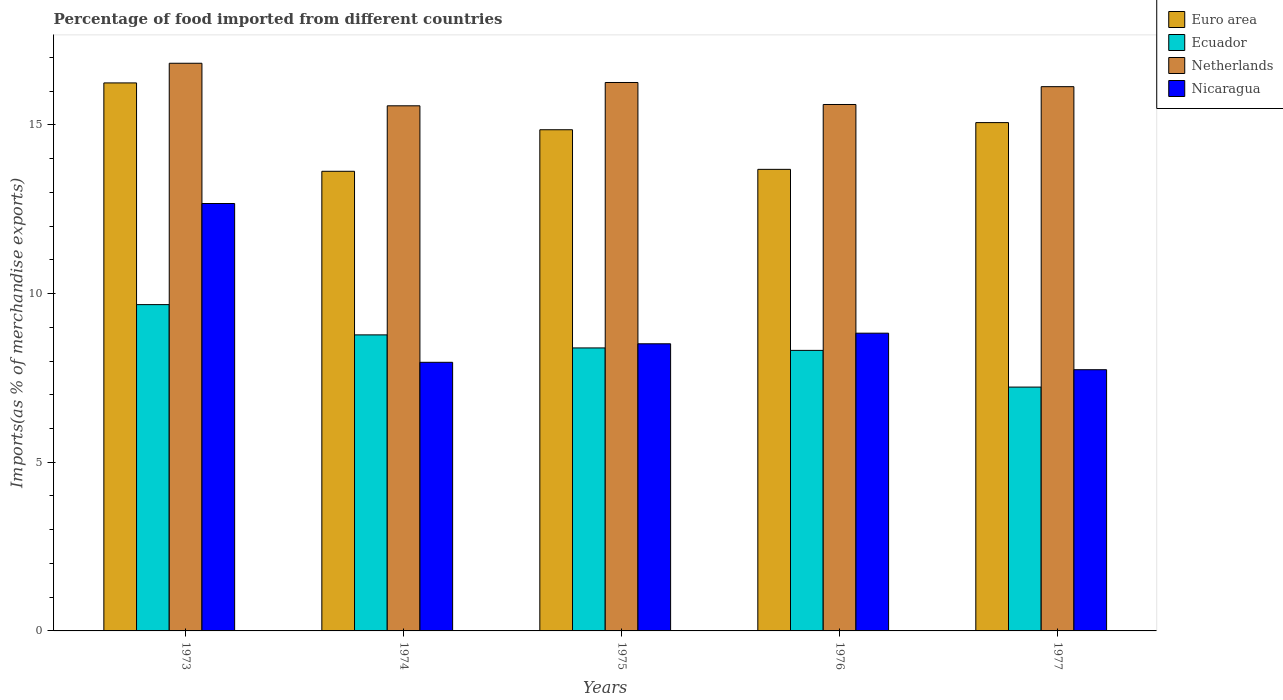How many different coloured bars are there?
Your answer should be compact. 4. Are the number of bars on each tick of the X-axis equal?
Ensure brevity in your answer.  Yes. How many bars are there on the 3rd tick from the right?
Offer a very short reply. 4. What is the label of the 2nd group of bars from the left?
Your answer should be compact. 1974. In how many cases, is the number of bars for a given year not equal to the number of legend labels?
Make the answer very short. 0. What is the percentage of imports to different countries in Ecuador in 1974?
Keep it short and to the point. 8.78. Across all years, what is the maximum percentage of imports to different countries in Nicaragua?
Give a very brief answer. 12.67. Across all years, what is the minimum percentage of imports to different countries in Euro area?
Provide a short and direct response. 13.63. What is the total percentage of imports to different countries in Ecuador in the graph?
Your answer should be compact. 42.38. What is the difference between the percentage of imports to different countries in Ecuador in 1973 and that in 1974?
Provide a succinct answer. 0.9. What is the difference between the percentage of imports to different countries in Ecuador in 1973 and the percentage of imports to different countries in Nicaragua in 1977?
Your answer should be compact. 1.93. What is the average percentage of imports to different countries in Euro area per year?
Provide a short and direct response. 14.7. In the year 1974, what is the difference between the percentage of imports to different countries in Ecuador and percentage of imports to different countries in Netherlands?
Your response must be concise. -6.79. In how many years, is the percentage of imports to different countries in Ecuador greater than 1 %?
Ensure brevity in your answer.  5. What is the ratio of the percentage of imports to different countries in Euro area in 1973 to that in 1977?
Keep it short and to the point. 1.08. Is the percentage of imports to different countries in Ecuador in 1974 less than that in 1977?
Make the answer very short. No. Is the difference between the percentage of imports to different countries in Ecuador in 1974 and 1975 greater than the difference between the percentage of imports to different countries in Netherlands in 1974 and 1975?
Ensure brevity in your answer.  Yes. What is the difference between the highest and the second highest percentage of imports to different countries in Netherlands?
Make the answer very short. 0.57. What is the difference between the highest and the lowest percentage of imports to different countries in Euro area?
Offer a terse response. 2.62. In how many years, is the percentage of imports to different countries in Ecuador greater than the average percentage of imports to different countries in Ecuador taken over all years?
Your answer should be compact. 2. Is it the case that in every year, the sum of the percentage of imports to different countries in Euro area and percentage of imports to different countries in Nicaragua is greater than the sum of percentage of imports to different countries in Ecuador and percentage of imports to different countries in Netherlands?
Offer a very short reply. No. What does the 1st bar from the right in 1976 represents?
Offer a terse response. Nicaragua. Are all the bars in the graph horizontal?
Give a very brief answer. No. What is the difference between two consecutive major ticks on the Y-axis?
Your answer should be very brief. 5. Does the graph contain grids?
Provide a succinct answer. No. Where does the legend appear in the graph?
Offer a terse response. Top right. How are the legend labels stacked?
Keep it short and to the point. Vertical. What is the title of the graph?
Keep it short and to the point. Percentage of food imported from different countries. Does "Malaysia" appear as one of the legend labels in the graph?
Keep it short and to the point. No. What is the label or title of the Y-axis?
Provide a short and direct response. Imports(as % of merchandise exports). What is the Imports(as % of merchandise exports) in Euro area in 1973?
Offer a terse response. 16.25. What is the Imports(as % of merchandise exports) of Ecuador in 1973?
Your response must be concise. 9.67. What is the Imports(as % of merchandise exports) of Netherlands in 1973?
Your response must be concise. 16.83. What is the Imports(as % of merchandise exports) in Nicaragua in 1973?
Offer a terse response. 12.67. What is the Imports(as % of merchandise exports) of Euro area in 1974?
Ensure brevity in your answer.  13.63. What is the Imports(as % of merchandise exports) of Ecuador in 1974?
Your response must be concise. 8.78. What is the Imports(as % of merchandise exports) in Netherlands in 1974?
Give a very brief answer. 15.57. What is the Imports(as % of merchandise exports) of Nicaragua in 1974?
Provide a short and direct response. 7.96. What is the Imports(as % of merchandise exports) of Euro area in 1975?
Provide a succinct answer. 14.86. What is the Imports(as % of merchandise exports) of Ecuador in 1975?
Provide a short and direct response. 8.39. What is the Imports(as % of merchandise exports) of Netherlands in 1975?
Give a very brief answer. 16.26. What is the Imports(as % of merchandise exports) in Nicaragua in 1975?
Ensure brevity in your answer.  8.51. What is the Imports(as % of merchandise exports) in Euro area in 1976?
Give a very brief answer. 13.68. What is the Imports(as % of merchandise exports) of Ecuador in 1976?
Make the answer very short. 8.32. What is the Imports(as % of merchandise exports) of Netherlands in 1976?
Your answer should be very brief. 15.61. What is the Imports(as % of merchandise exports) of Nicaragua in 1976?
Provide a short and direct response. 8.83. What is the Imports(as % of merchandise exports) of Euro area in 1977?
Your answer should be compact. 15.07. What is the Imports(as % of merchandise exports) of Ecuador in 1977?
Make the answer very short. 7.23. What is the Imports(as % of merchandise exports) of Netherlands in 1977?
Your answer should be very brief. 16.13. What is the Imports(as % of merchandise exports) of Nicaragua in 1977?
Provide a succinct answer. 7.74. Across all years, what is the maximum Imports(as % of merchandise exports) of Euro area?
Give a very brief answer. 16.25. Across all years, what is the maximum Imports(as % of merchandise exports) in Ecuador?
Offer a very short reply. 9.67. Across all years, what is the maximum Imports(as % of merchandise exports) of Netherlands?
Provide a succinct answer. 16.83. Across all years, what is the maximum Imports(as % of merchandise exports) in Nicaragua?
Offer a terse response. 12.67. Across all years, what is the minimum Imports(as % of merchandise exports) of Euro area?
Make the answer very short. 13.63. Across all years, what is the minimum Imports(as % of merchandise exports) in Ecuador?
Make the answer very short. 7.23. Across all years, what is the minimum Imports(as % of merchandise exports) of Netherlands?
Your answer should be very brief. 15.57. Across all years, what is the minimum Imports(as % of merchandise exports) in Nicaragua?
Offer a terse response. 7.74. What is the total Imports(as % of merchandise exports) of Euro area in the graph?
Offer a very short reply. 73.48. What is the total Imports(as % of merchandise exports) in Ecuador in the graph?
Give a very brief answer. 42.38. What is the total Imports(as % of merchandise exports) in Netherlands in the graph?
Make the answer very short. 80.39. What is the total Imports(as % of merchandise exports) of Nicaragua in the graph?
Offer a very short reply. 45.71. What is the difference between the Imports(as % of merchandise exports) in Euro area in 1973 and that in 1974?
Make the answer very short. 2.62. What is the difference between the Imports(as % of merchandise exports) of Ecuador in 1973 and that in 1974?
Ensure brevity in your answer.  0.9. What is the difference between the Imports(as % of merchandise exports) in Netherlands in 1973 and that in 1974?
Make the answer very short. 1.26. What is the difference between the Imports(as % of merchandise exports) in Nicaragua in 1973 and that in 1974?
Your answer should be very brief. 4.71. What is the difference between the Imports(as % of merchandise exports) in Euro area in 1973 and that in 1975?
Make the answer very short. 1.39. What is the difference between the Imports(as % of merchandise exports) in Ecuador in 1973 and that in 1975?
Give a very brief answer. 1.28. What is the difference between the Imports(as % of merchandise exports) of Netherlands in 1973 and that in 1975?
Offer a very short reply. 0.57. What is the difference between the Imports(as % of merchandise exports) in Nicaragua in 1973 and that in 1975?
Offer a very short reply. 4.16. What is the difference between the Imports(as % of merchandise exports) of Euro area in 1973 and that in 1976?
Your answer should be very brief. 2.56. What is the difference between the Imports(as % of merchandise exports) of Ecuador in 1973 and that in 1976?
Ensure brevity in your answer.  1.36. What is the difference between the Imports(as % of merchandise exports) in Netherlands in 1973 and that in 1976?
Give a very brief answer. 1.22. What is the difference between the Imports(as % of merchandise exports) in Nicaragua in 1973 and that in 1976?
Your response must be concise. 3.84. What is the difference between the Imports(as % of merchandise exports) in Euro area in 1973 and that in 1977?
Ensure brevity in your answer.  1.18. What is the difference between the Imports(as % of merchandise exports) in Ecuador in 1973 and that in 1977?
Give a very brief answer. 2.44. What is the difference between the Imports(as % of merchandise exports) in Netherlands in 1973 and that in 1977?
Your response must be concise. 0.69. What is the difference between the Imports(as % of merchandise exports) of Nicaragua in 1973 and that in 1977?
Offer a very short reply. 4.93. What is the difference between the Imports(as % of merchandise exports) in Euro area in 1974 and that in 1975?
Your answer should be very brief. -1.23. What is the difference between the Imports(as % of merchandise exports) in Ecuador in 1974 and that in 1975?
Provide a short and direct response. 0.39. What is the difference between the Imports(as % of merchandise exports) in Netherlands in 1974 and that in 1975?
Your response must be concise. -0.69. What is the difference between the Imports(as % of merchandise exports) of Nicaragua in 1974 and that in 1975?
Offer a terse response. -0.55. What is the difference between the Imports(as % of merchandise exports) in Euro area in 1974 and that in 1976?
Your answer should be compact. -0.06. What is the difference between the Imports(as % of merchandise exports) in Ecuador in 1974 and that in 1976?
Provide a short and direct response. 0.46. What is the difference between the Imports(as % of merchandise exports) of Netherlands in 1974 and that in 1976?
Offer a very short reply. -0.04. What is the difference between the Imports(as % of merchandise exports) in Nicaragua in 1974 and that in 1976?
Provide a succinct answer. -0.86. What is the difference between the Imports(as % of merchandise exports) in Euro area in 1974 and that in 1977?
Give a very brief answer. -1.44. What is the difference between the Imports(as % of merchandise exports) in Ecuador in 1974 and that in 1977?
Provide a short and direct response. 1.55. What is the difference between the Imports(as % of merchandise exports) in Netherlands in 1974 and that in 1977?
Provide a short and direct response. -0.57. What is the difference between the Imports(as % of merchandise exports) in Nicaragua in 1974 and that in 1977?
Provide a succinct answer. 0.22. What is the difference between the Imports(as % of merchandise exports) in Euro area in 1975 and that in 1976?
Offer a very short reply. 1.17. What is the difference between the Imports(as % of merchandise exports) of Ecuador in 1975 and that in 1976?
Give a very brief answer. 0.07. What is the difference between the Imports(as % of merchandise exports) in Netherlands in 1975 and that in 1976?
Keep it short and to the point. 0.65. What is the difference between the Imports(as % of merchandise exports) of Nicaragua in 1975 and that in 1976?
Offer a terse response. -0.31. What is the difference between the Imports(as % of merchandise exports) in Euro area in 1975 and that in 1977?
Your answer should be very brief. -0.21. What is the difference between the Imports(as % of merchandise exports) of Ecuador in 1975 and that in 1977?
Ensure brevity in your answer.  1.16. What is the difference between the Imports(as % of merchandise exports) in Netherlands in 1975 and that in 1977?
Your answer should be very brief. 0.12. What is the difference between the Imports(as % of merchandise exports) of Nicaragua in 1975 and that in 1977?
Make the answer very short. 0.77. What is the difference between the Imports(as % of merchandise exports) of Euro area in 1976 and that in 1977?
Make the answer very short. -1.39. What is the difference between the Imports(as % of merchandise exports) of Ecuador in 1976 and that in 1977?
Keep it short and to the point. 1.09. What is the difference between the Imports(as % of merchandise exports) of Netherlands in 1976 and that in 1977?
Offer a very short reply. -0.53. What is the difference between the Imports(as % of merchandise exports) in Nicaragua in 1976 and that in 1977?
Make the answer very short. 1.08. What is the difference between the Imports(as % of merchandise exports) in Euro area in 1973 and the Imports(as % of merchandise exports) in Ecuador in 1974?
Provide a succinct answer. 7.47. What is the difference between the Imports(as % of merchandise exports) of Euro area in 1973 and the Imports(as % of merchandise exports) of Netherlands in 1974?
Your answer should be compact. 0.68. What is the difference between the Imports(as % of merchandise exports) in Euro area in 1973 and the Imports(as % of merchandise exports) in Nicaragua in 1974?
Ensure brevity in your answer.  8.28. What is the difference between the Imports(as % of merchandise exports) of Ecuador in 1973 and the Imports(as % of merchandise exports) of Netherlands in 1974?
Ensure brevity in your answer.  -5.89. What is the difference between the Imports(as % of merchandise exports) in Ecuador in 1973 and the Imports(as % of merchandise exports) in Nicaragua in 1974?
Ensure brevity in your answer.  1.71. What is the difference between the Imports(as % of merchandise exports) in Netherlands in 1973 and the Imports(as % of merchandise exports) in Nicaragua in 1974?
Provide a succinct answer. 8.86. What is the difference between the Imports(as % of merchandise exports) in Euro area in 1973 and the Imports(as % of merchandise exports) in Ecuador in 1975?
Your answer should be very brief. 7.86. What is the difference between the Imports(as % of merchandise exports) of Euro area in 1973 and the Imports(as % of merchandise exports) of Netherlands in 1975?
Your answer should be very brief. -0.01. What is the difference between the Imports(as % of merchandise exports) in Euro area in 1973 and the Imports(as % of merchandise exports) in Nicaragua in 1975?
Your answer should be compact. 7.73. What is the difference between the Imports(as % of merchandise exports) in Ecuador in 1973 and the Imports(as % of merchandise exports) in Netherlands in 1975?
Your response must be concise. -6.58. What is the difference between the Imports(as % of merchandise exports) in Ecuador in 1973 and the Imports(as % of merchandise exports) in Nicaragua in 1975?
Offer a terse response. 1.16. What is the difference between the Imports(as % of merchandise exports) in Netherlands in 1973 and the Imports(as % of merchandise exports) in Nicaragua in 1975?
Your answer should be very brief. 8.32. What is the difference between the Imports(as % of merchandise exports) in Euro area in 1973 and the Imports(as % of merchandise exports) in Ecuador in 1976?
Your answer should be compact. 7.93. What is the difference between the Imports(as % of merchandise exports) in Euro area in 1973 and the Imports(as % of merchandise exports) in Netherlands in 1976?
Your answer should be compact. 0.64. What is the difference between the Imports(as % of merchandise exports) in Euro area in 1973 and the Imports(as % of merchandise exports) in Nicaragua in 1976?
Your answer should be very brief. 7.42. What is the difference between the Imports(as % of merchandise exports) of Ecuador in 1973 and the Imports(as % of merchandise exports) of Netherlands in 1976?
Your response must be concise. -5.93. What is the difference between the Imports(as % of merchandise exports) in Ecuador in 1973 and the Imports(as % of merchandise exports) in Nicaragua in 1976?
Offer a very short reply. 0.85. What is the difference between the Imports(as % of merchandise exports) of Netherlands in 1973 and the Imports(as % of merchandise exports) of Nicaragua in 1976?
Provide a short and direct response. 8. What is the difference between the Imports(as % of merchandise exports) in Euro area in 1973 and the Imports(as % of merchandise exports) in Ecuador in 1977?
Your answer should be very brief. 9.02. What is the difference between the Imports(as % of merchandise exports) of Euro area in 1973 and the Imports(as % of merchandise exports) of Netherlands in 1977?
Provide a short and direct response. 0.11. What is the difference between the Imports(as % of merchandise exports) in Euro area in 1973 and the Imports(as % of merchandise exports) in Nicaragua in 1977?
Your response must be concise. 8.5. What is the difference between the Imports(as % of merchandise exports) of Ecuador in 1973 and the Imports(as % of merchandise exports) of Netherlands in 1977?
Offer a terse response. -6.46. What is the difference between the Imports(as % of merchandise exports) of Ecuador in 1973 and the Imports(as % of merchandise exports) of Nicaragua in 1977?
Make the answer very short. 1.93. What is the difference between the Imports(as % of merchandise exports) in Netherlands in 1973 and the Imports(as % of merchandise exports) in Nicaragua in 1977?
Offer a terse response. 9.08. What is the difference between the Imports(as % of merchandise exports) of Euro area in 1974 and the Imports(as % of merchandise exports) of Ecuador in 1975?
Keep it short and to the point. 5.24. What is the difference between the Imports(as % of merchandise exports) in Euro area in 1974 and the Imports(as % of merchandise exports) in Netherlands in 1975?
Provide a succinct answer. -2.63. What is the difference between the Imports(as % of merchandise exports) of Euro area in 1974 and the Imports(as % of merchandise exports) of Nicaragua in 1975?
Give a very brief answer. 5.11. What is the difference between the Imports(as % of merchandise exports) in Ecuador in 1974 and the Imports(as % of merchandise exports) in Netherlands in 1975?
Provide a succinct answer. -7.48. What is the difference between the Imports(as % of merchandise exports) in Ecuador in 1974 and the Imports(as % of merchandise exports) in Nicaragua in 1975?
Your answer should be very brief. 0.26. What is the difference between the Imports(as % of merchandise exports) in Netherlands in 1974 and the Imports(as % of merchandise exports) in Nicaragua in 1975?
Offer a terse response. 7.06. What is the difference between the Imports(as % of merchandise exports) in Euro area in 1974 and the Imports(as % of merchandise exports) in Ecuador in 1976?
Keep it short and to the point. 5.31. What is the difference between the Imports(as % of merchandise exports) in Euro area in 1974 and the Imports(as % of merchandise exports) in Netherlands in 1976?
Provide a short and direct response. -1.98. What is the difference between the Imports(as % of merchandise exports) in Euro area in 1974 and the Imports(as % of merchandise exports) in Nicaragua in 1976?
Provide a succinct answer. 4.8. What is the difference between the Imports(as % of merchandise exports) in Ecuador in 1974 and the Imports(as % of merchandise exports) in Netherlands in 1976?
Provide a short and direct response. -6.83. What is the difference between the Imports(as % of merchandise exports) in Ecuador in 1974 and the Imports(as % of merchandise exports) in Nicaragua in 1976?
Provide a succinct answer. -0.05. What is the difference between the Imports(as % of merchandise exports) in Netherlands in 1974 and the Imports(as % of merchandise exports) in Nicaragua in 1976?
Ensure brevity in your answer.  6.74. What is the difference between the Imports(as % of merchandise exports) of Euro area in 1974 and the Imports(as % of merchandise exports) of Ecuador in 1977?
Provide a succinct answer. 6.4. What is the difference between the Imports(as % of merchandise exports) of Euro area in 1974 and the Imports(as % of merchandise exports) of Netherlands in 1977?
Give a very brief answer. -2.51. What is the difference between the Imports(as % of merchandise exports) of Euro area in 1974 and the Imports(as % of merchandise exports) of Nicaragua in 1977?
Give a very brief answer. 5.88. What is the difference between the Imports(as % of merchandise exports) in Ecuador in 1974 and the Imports(as % of merchandise exports) in Netherlands in 1977?
Your response must be concise. -7.36. What is the difference between the Imports(as % of merchandise exports) of Ecuador in 1974 and the Imports(as % of merchandise exports) of Nicaragua in 1977?
Ensure brevity in your answer.  1.03. What is the difference between the Imports(as % of merchandise exports) in Netherlands in 1974 and the Imports(as % of merchandise exports) in Nicaragua in 1977?
Offer a very short reply. 7.82. What is the difference between the Imports(as % of merchandise exports) in Euro area in 1975 and the Imports(as % of merchandise exports) in Ecuador in 1976?
Offer a terse response. 6.54. What is the difference between the Imports(as % of merchandise exports) in Euro area in 1975 and the Imports(as % of merchandise exports) in Netherlands in 1976?
Provide a short and direct response. -0.75. What is the difference between the Imports(as % of merchandise exports) in Euro area in 1975 and the Imports(as % of merchandise exports) in Nicaragua in 1976?
Keep it short and to the point. 6.03. What is the difference between the Imports(as % of merchandise exports) in Ecuador in 1975 and the Imports(as % of merchandise exports) in Netherlands in 1976?
Give a very brief answer. -7.22. What is the difference between the Imports(as % of merchandise exports) of Ecuador in 1975 and the Imports(as % of merchandise exports) of Nicaragua in 1976?
Ensure brevity in your answer.  -0.44. What is the difference between the Imports(as % of merchandise exports) in Netherlands in 1975 and the Imports(as % of merchandise exports) in Nicaragua in 1976?
Offer a terse response. 7.43. What is the difference between the Imports(as % of merchandise exports) in Euro area in 1975 and the Imports(as % of merchandise exports) in Ecuador in 1977?
Offer a very short reply. 7.63. What is the difference between the Imports(as % of merchandise exports) of Euro area in 1975 and the Imports(as % of merchandise exports) of Netherlands in 1977?
Your response must be concise. -1.28. What is the difference between the Imports(as % of merchandise exports) in Euro area in 1975 and the Imports(as % of merchandise exports) in Nicaragua in 1977?
Your answer should be very brief. 7.11. What is the difference between the Imports(as % of merchandise exports) in Ecuador in 1975 and the Imports(as % of merchandise exports) in Netherlands in 1977?
Keep it short and to the point. -7.75. What is the difference between the Imports(as % of merchandise exports) in Ecuador in 1975 and the Imports(as % of merchandise exports) in Nicaragua in 1977?
Provide a short and direct response. 0.65. What is the difference between the Imports(as % of merchandise exports) of Netherlands in 1975 and the Imports(as % of merchandise exports) of Nicaragua in 1977?
Provide a short and direct response. 8.51. What is the difference between the Imports(as % of merchandise exports) in Euro area in 1976 and the Imports(as % of merchandise exports) in Ecuador in 1977?
Give a very brief answer. 6.45. What is the difference between the Imports(as % of merchandise exports) in Euro area in 1976 and the Imports(as % of merchandise exports) in Netherlands in 1977?
Your response must be concise. -2.45. What is the difference between the Imports(as % of merchandise exports) in Euro area in 1976 and the Imports(as % of merchandise exports) in Nicaragua in 1977?
Give a very brief answer. 5.94. What is the difference between the Imports(as % of merchandise exports) in Ecuador in 1976 and the Imports(as % of merchandise exports) in Netherlands in 1977?
Give a very brief answer. -7.82. What is the difference between the Imports(as % of merchandise exports) in Ecuador in 1976 and the Imports(as % of merchandise exports) in Nicaragua in 1977?
Ensure brevity in your answer.  0.57. What is the difference between the Imports(as % of merchandise exports) in Netherlands in 1976 and the Imports(as % of merchandise exports) in Nicaragua in 1977?
Provide a succinct answer. 7.86. What is the average Imports(as % of merchandise exports) of Euro area per year?
Your answer should be very brief. 14.7. What is the average Imports(as % of merchandise exports) of Ecuador per year?
Provide a short and direct response. 8.48. What is the average Imports(as % of merchandise exports) in Netherlands per year?
Provide a succinct answer. 16.08. What is the average Imports(as % of merchandise exports) in Nicaragua per year?
Offer a terse response. 9.14. In the year 1973, what is the difference between the Imports(as % of merchandise exports) in Euro area and Imports(as % of merchandise exports) in Ecuador?
Keep it short and to the point. 6.57. In the year 1973, what is the difference between the Imports(as % of merchandise exports) of Euro area and Imports(as % of merchandise exports) of Netherlands?
Ensure brevity in your answer.  -0.58. In the year 1973, what is the difference between the Imports(as % of merchandise exports) of Euro area and Imports(as % of merchandise exports) of Nicaragua?
Your answer should be very brief. 3.57. In the year 1973, what is the difference between the Imports(as % of merchandise exports) in Ecuador and Imports(as % of merchandise exports) in Netherlands?
Offer a very short reply. -7.16. In the year 1973, what is the difference between the Imports(as % of merchandise exports) of Ecuador and Imports(as % of merchandise exports) of Nicaragua?
Provide a short and direct response. -3. In the year 1973, what is the difference between the Imports(as % of merchandise exports) in Netherlands and Imports(as % of merchandise exports) in Nicaragua?
Ensure brevity in your answer.  4.16. In the year 1974, what is the difference between the Imports(as % of merchandise exports) of Euro area and Imports(as % of merchandise exports) of Ecuador?
Provide a short and direct response. 4.85. In the year 1974, what is the difference between the Imports(as % of merchandise exports) of Euro area and Imports(as % of merchandise exports) of Netherlands?
Ensure brevity in your answer.  -1.94. In the year 1974, what is the difference between the Imports(as % of merchandise exports) in Euro area and Imports(as % of merchandise exports) in Nicaragua?
Your answer should be very brief. 5.66. In the year 1974, what is the difference between the Imports(as % of merchandise exports) in Ecuador and Imports(as % of merchandise exports) in Netherlands?
Your answer should be compact. -6.79. In the year 1974, what is the difference between the Imports(as % of merchandise exports) in Ecuador and Imports(as % of merchandise exports) in Nicaragua?
Offer a terse response. 0.81. In the year 1974, what is the difference between the Imports(as % of merchandise exports) in Netherlands and Imports(as % of merchandise exports) in Nicaragua?
Keep it short and to the point. 7.6. In the year 1975, what is the difference between the Imports(as % of merchandise exports) in Euro area and Imports(as % of merchandise exports) in Ecuador?
Give a very brief answer. 6.47. In the year 1975, what is the difference between the Imports(as % of merchandise exports) in Euro area and Imports(as % of merchandise exports) in Netherlands?
Your answer should be very brief. -1.4. In the year 1975, what is the difference between the Imports(as % of merchandise exports) of Euro area and Imports(as % of merchandise exports) of Nicaragua?
Ensure brevity in your answer.  6.35. In the year 1975, what is the difference between the Imports(as % of merchandise exports) of Ecuador and Imports(as % of merchandise exports) of Netherlands?
Your answer should be compact. -7.87. In the year 1975, what is the difference between the Imports(as % of merchandise exports) in Ecuador and Imports(as % of merchandise exports) in Nicaragua?
Keep it short and to the point. -0.12. In the year 1975, what is the difference between the Imports(as % of merchandise exports) of Netherlands and Imports(as % of merchandise exports) of Nicaragua?
Make the answer very short. 7.75. In the year 1976, what is the difference between the Imports(as % of merchandise exports) in Euro area and Imports(as % of merchandise exports) in Ecuador?
Your answer should be very brief. 5.37. In the year 1976, what is the difference between the Imports(as % of merchandise exports) in Euro area and Imports(as % of merchandise exports) in Netherlands?
Make the answer very short. -1.92. In the year 1976, what is the difference between the Imports(as % of merchandise exports) of Euro area and Imports(as % of merchandise exports) of Nicaragua?
Offer a terse response. 4.86. In the year 1976, what is the difference between the Imports(as % of merchandise exports) in Ecuador and Imports(as % of merchandise exports) in Netherlands?
Provide a succinct answer. -7.29. In the year 1976, what is the difference between the Imports(as % of merchandise exports) of Ecuador and Imports(as % of merchandise exports) of Nicaragua?
Keep it short and to the point. -0.51. In the year 1976, what is the difference between the Imports(as % of merchandise exports) in Netherlands and Imports(as % of merchandise exports) in Nicaragua?
Make the answer very short. 6.78. In the year 1977, what is the difference between the Imports(as % of merchandise exports) of Euro area and Imports(as % of merchandise exports) of Ecuador?
Your answer should be very brief. 7.84. In the year 1977, what is the difference between the Imports(as % of merchandise exports) in Euro area and Imports(as % of merchandise exports) in Netherlands?
Your response must be concise. -1.07. In the year 1977, what is the difference between the Imports(as % of merchandise exports) of Euro area and Imports(as % of merchandise exports) of Nicaragua?
Offer a very short reply. 7.33. In the year 1977, what is the difference between the Imports(as % of merchandise exports) in Ecuador and Imports(as % of merchandise exports) in Netherlands?
Provide a short and direct response. -8.91. In the year 1977, what is the difference between the Imports(as % of merchandise exports) in Ecuador and Imports(as % of merchandise exports) in Nicaragua?
Your answer should be very brief. -0.51. In the year 1977, what is the difference between the Imports(as % of merchandise exports) of Netherlands and Imports(as % of merchandise exports) of Nicaragua?
Provide a short and direct response. 8.39. What is the ratio of the Imports(as % of merchandise exports) of Euro area in 1973 to that in 1974?
Offer a terse response. 1.19. What is the ratio of the Imports(as % of merchandise exports) in Ecuador in 1973 to that in 1974?
Your response must be concise. 1.1. What is the ratio of the Imports(as % of merchandise exports) of Netherlands in 1973 to that in 1974?
Offer a terse response. 1.08. What is the ratio of the Imports(as % of merchandise exports) of Nicaragua in 1973 to that in 1974?
Give a very brief answer. 1.59. What is the ratio of the Imports(as % of merchandise exports) in Euro area in 1973 to that in 1975?
Make the answer very short. 1.09. What is the ratio of the Imports(as % of merchandise exports) of Ecuador in 1973 to that in 1975?
Keep it short and to the point. 1.15. What is the ratio of the Imports(as % of merchandise exports) in Netherlands in 1973 to that in 1975?
Your answer should be compact. 1.04. What is the ratio of the Imports(as % of merchandise exports) in Nicaragua in 1973 to that in 1975?
Your answer should be very brief. 1.49. What is the ratio of the Imports(as % of merchandise exports) of Euro area in 1973 to that in 1976?
Make the answer very short. 1.19. What is the ratio of the Imports(as % of merchandise exports) of Ecuador in 1973 to that in 1976?
Offer a very short reply. 1.16. What is the ratio of the Imports(as % of merchandise exports) of Netherlands in 1973 to that in 1976?
Ensure brevity in your answer.  1.08. What is the ratio of the Imports(as % of merchandise exports) in Nicaragua in 1973 to that in 1976?
Provide a succinct answer. 1.44. What is the ratio of the Imports(as % of merchandise exports) of Euro area in 1973 to that in 1977?
Provide a short and direct response. 1.08. What is the ratio of the Imports(as % of merchandise exports) in Ecuador in 1973 to that in 1977?
Keep it short and to the point. 1.34. What is the ratio of the Imports(as % of merchandise exports) in Netherlands in 1973 to that in 1977?
Provide a succinct answer. 1.04. What is the ratio of the Imports(as % of merchandise exports) of Nicaragua in 1973 to that in 1977?
Your answer should be compact. 1.64. What is the ratio of the Imports(as % of merchandise exports) in Euro area in 1974 to that in 1975?
Provide a succinct answer. 0.92. What is the ratio of the Imports(as % of merchandise exports) of Ecuador in 1974 to that in 1975?
Offer a very short reply. 1.05. What is the ratio of the Imports(as % of merchandise exports) of Netherlands in 1974 to that in 1975?
Provide a succinct answer. 0.96. What is the ratio of the Imports(as % of merchandise exports) of Nicaragua in 1974 to that in 1975?
Your response must be concise. 0.94. What is the ratio of the Imports(as % of merchandise exports) in Euro area in 1974 to that in 1976?
Your answer should be compact. 1. What is the ratio of the Imports(as % of merchandise exports) in Ecuador in 1974 to that in 1976?
Offer a terse response. 1.06. What is the ratio of the Imports(as % of merchandise exports) in Netherlands in 1974 to that in 1976?
Keep it short and to the point. 1. What is the ratio of the Imports(as % of merchandise exports) of Nicaragua in 1974 to that in 1976?
Offer a terse response. 0.9. What is the ratio of the Imports(as % of merchandise exports) in Euro area in 1974 to that in 1977?
Keep it short and to the point. 0.9. What is the ratio of the Imports(as % of merchandise exports) of Ecuador in 1974 to that in 1977?
Make the answer very short. 1.21. What is the ratio of the Imports(as % of merchandise exports) in Netherlands in 1974 to that in 1977?
Provide a short and direct response. 0.96. What is the ratio of the Imports(as % of merchandise exports) in Nicaragua in 1974 to that in 1977?
Provide a short and direct response. 1.03. What is the ratio of the Imports(as % of merchandise exports) in Euro area in 1975 to that in 1976?
Your answer should be compact. 1.09. What is the ratio of the Imports(as % of merchandise exports) in Ecuador in 1975 to that in 1976?
Provide a short and direct response. 1.01. What is the ratio of the Imports(as % of merchandise exports) in Netherlands in 1975 to that in 1976?
Your response must be concise. 1.04. What is the ratio of the Imports(as % of merchandise exports) of Nicaragua in 1975 to that in 1976?
Your answer should be very brief. 0.96. What is the ratio of the Imports(as % of merchandise exports) of Ecuador in 1975 to that in 1977?
Your answer should be very brief. 1.16. What is the ratio of the Imports(as % of merchandise exports) in Netherlands in 1975 to that in 1977?
Offer a very short reply. 1.01. What is the ratio of the Imports(as % of merchandise exports) of Nicaragua in 1975 to that in 1977?
Make the answer very short. 1.1. What is the ratio of the Imports(as % of merchandise exports) of Euro area in 1976 to that in 1977?
Provide a succinct answer. 0.91. What is the ratio of the Imports(as % of merchandise exports) of Ecuador in 1976 to that in 1977?
Give a very brief answer. 1.15. What is the ratio of the Imports(as % of merchandise exports) in Netherlands in 1976 to that in 1977?
Offer a terse response. 0.97. What is the ratio of the Imports(as % of merchandise exports) of Nicaragua in 1976 to that in 1977?
Your answer should be compact. 1.14. What is the difference between the highest and the second highest Imports(as % of merchandise exports) of Euro area?
Give a very brief answer. 1.18. What is the difference between the highest and the second highest Imports(as % of merchandise exports) in Ecuador?
Keep it short and to the point. 0.9. What is the difference between the highest and the second highest Imports(as % of merchandise exports) of Netherlands?
Make the answer very short. 0.57. What is the difference between the highest and the second highest Imports(as % of merchandise exports) of Nicaragua?
Ensure brevity in your answer.  3.84. What is the difference between the highest and the lowest Imports(as % of merchandise exports) of Euro area?
Keep it short and to the point. 2.62. What is the difference between the highest and the lowest Imports(as % of merchandise exports) in Ecuador?
Your response must be concise. 2.44. What is the difference between the highest and the lowest Imports(as % of merchandise exports) of Netherlands?
Give a very brief answer. 1.26. What is the difference between the highest and the lowest Imports(as % of merchandise exports) in Nicaragua?
Give a very brief answer. 4.93. 